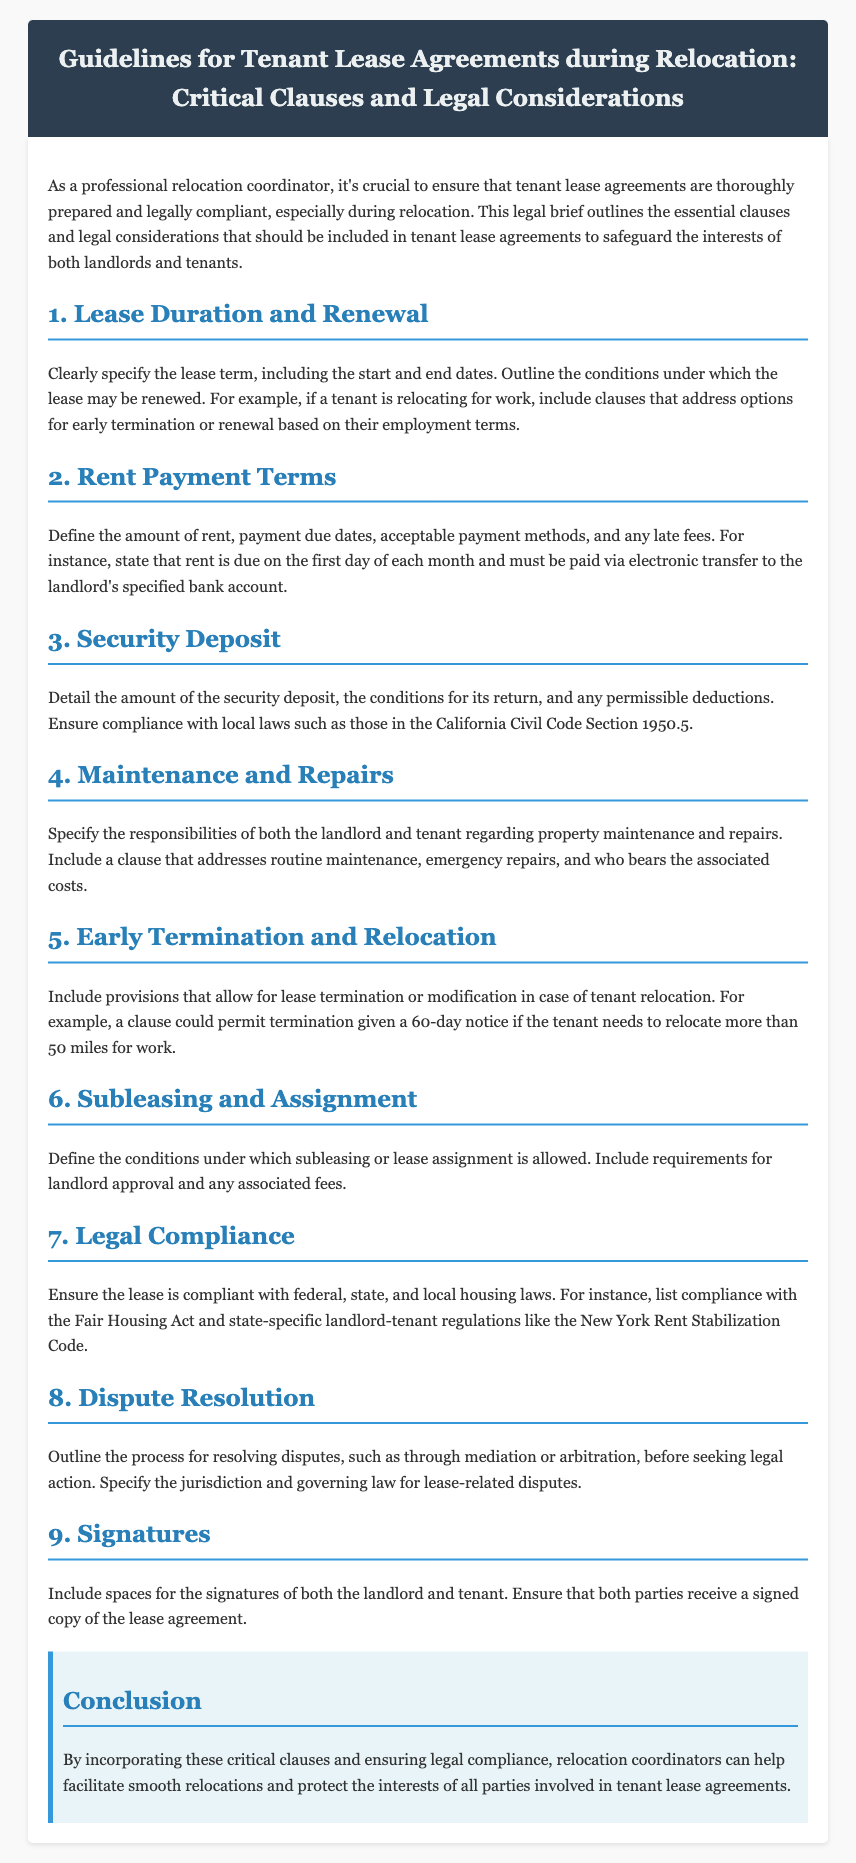What is the main purpose of the legal brief? The purpose is to outline essential clauses and legal considerations for tenant lease agreements during relocation.
Answer: To safeguard the interests of both landlords and tenants What section addresses early termination conditions? The section that discusses lease termination or modification in case of tenant relocation is titled "Early Termination and Relocation."
Answer: Early Termination and Relocation What must be clearly specified in the lease duration clause? The lease duration clause must specify the lease term, including the start and end dates.
Answer: Start and end dates What compliance is mentioned in relation to security deposits? The document mentions compliance with the California Civil Code Section 1950.5 regarding security deposits.
Answer: California Civil Code Section 1950.5 Under which section are maintenance responsibilities outlined? Responsibilities regarding property maintenance and repairs are detailed under the "Maintenance and Repairs" section.
Answer: Maintenance and Repairs What is required for subleasing according to the document? The lease must define conditions under which subleasing is allowed, including landlord approval.
Answer: Landlord approval What dispute resolution method is suggested? The document suggests mediation or arbitration as methods for resolving disputes.
Answer: Mediation or arbitration What must be included at the end of the lease agreement? Spaces for the signatures of both the landlord and tenant must be included.
Answer: Signatures What is the overarching theme of the conclusion? The conclusion emphasizes the importance of incorporating critical clauses for smooth relocations.
Answer: Smooth relocations 